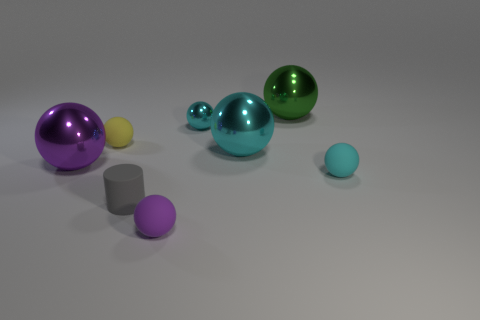Subtract all yellow spheres. How many spheres are left? 6 Subtract all yellow spheres. How many spheres are left? 6 Subtract all spheres. How many objects are left? 1 Add 1 cyan matte balls. How many objects exist? 9 Add 3 small cyan rubber balls. How many small cyan rubber balls exist? 4 Subtract 1 yellow spheres. How many objects are left? 7 Subtract 6 spheres. How many spheres are left? 1 Subtract all red cylinders. Subtract all gray blocks. How many cylinders are left? 1 Subtract all purple cylinders. How many green spheres are left? 1 Subtract all metallic objects. Subtract all green shiny things. How many objects are left? 3 